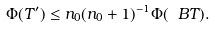<formula> <loc_0><loc_0><loc_500><loc_500>\Phi ( T ^ { \prime } ) \leq n _ { 0 } ( n _ { 0 } + 1 ) ^ { - 1 } \Phi ( \ B T ) .</formula> 